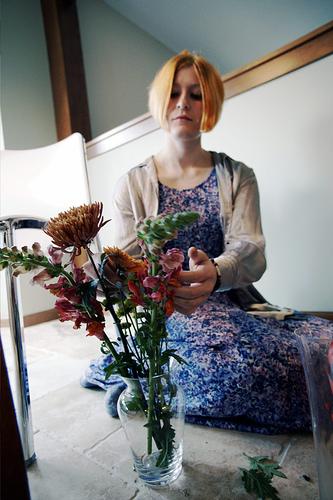Is the woman standing or sitting?
Give a very brief answer. Sitting. Is this woman trimming the plant?
Short answer required. Yes. Is the woman wearing a watch?
Keep it brief. Yes. What material is the wall made out of?
Quick response, please. Wood. What type of flowers are those?
Answer briefly. Lilies. 